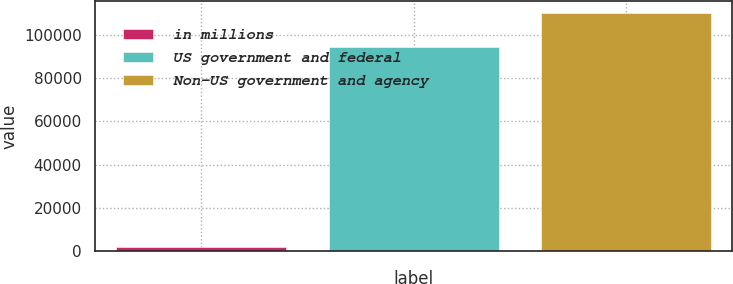<chart> <loc_0><loc_0><loc_500><loc_500><bar_chart><fcel>in millions<fcel>US government and federal<fcel>Non-US government and agency<nl><fcel>2011<fcel>94603<fcel>110178<nl></chart> 